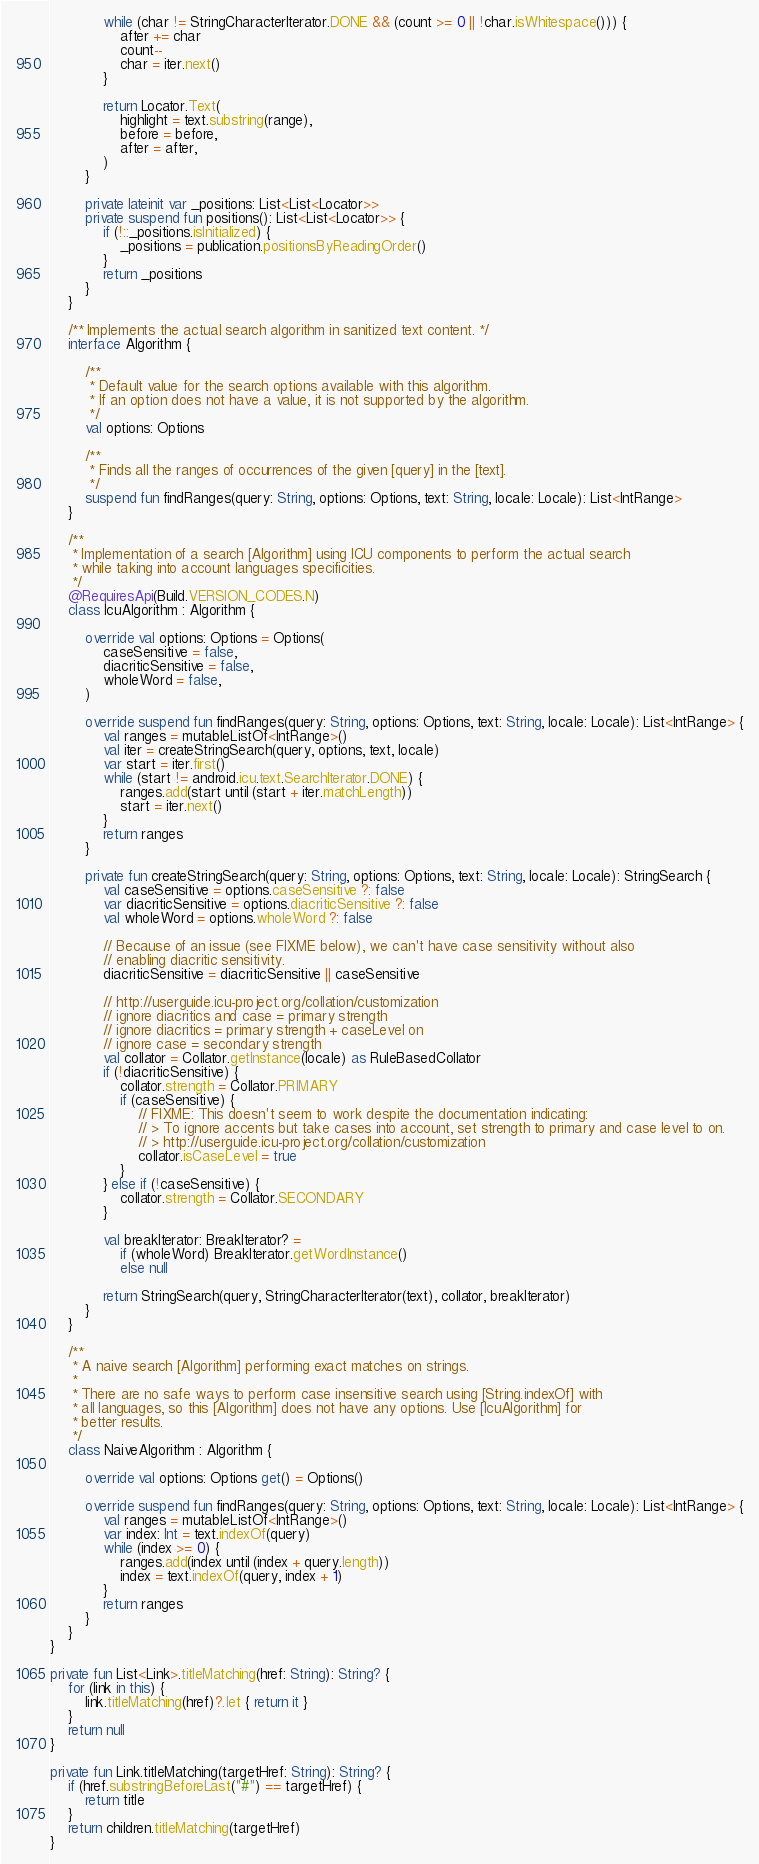Convert code to text. <code><loc_0><loc_0><loc_500><loc_500><_Kotlin_>            while (char != StringCharacterIterator.DONE && (count >= 0 || !char.isWhitespace())) {
                after += char
                count--
                char = iter.next()
            }

            return Locator.Text(
                highlight = text.substring(range),
                before = before,
                after = after,
            )
        }

        private lateinit var _positions: List<List<Locator>>
        private suspend fun positions(): List<List<Locator>> {
            if (!::_positions.isInitialized) {
                _positions = publication.positionsByReadingOrder()
            }
            return _positions
        }
    }

    /** Implements the actual search algorithm in sanitized text content. */
    interface Algorithm {

        /**
         * Default value for the search options available with this algorithm.
         * If an option does not have a value, it is not supported by the algorithm.
         */
        val options: Options

        /**
         * Finds all the ranges of occurrences of the given [query] in the [text].
         */
        suspend fun findRanges(query: String, options: Options, text: String, locale: Locale): List<IntRange>
    }

    /**
     * Implementation of a search [Algorithm] using ICU components to perform the actual search
     * while taking into account languages specificities.
     */
    @RequiresApi(Build.VERSION_CODES.N)
    class IcuAlgorithm : Algorithm {

        override val options: Options = Options(
            caseSensitive = false,
            diacriticSensitive = false,
            wholeWord = false,
        )

        override suspend fun findRanges(query: String, options: Options, text: String, locale: Locale): List<IntRange> {
            val ranges = mutableListOf<IntRange>()
            val iter = createStringSearch(query, options, text, locale)
            var start = iter.first()
            while (start != android.icu.text.SearchIterator.DONE) {
                ranges.add(start until (start + iter.matchLength))
                start = iter.next()
            }
            return ranges
        }

        private fun createStringSearch(query: String, options: Options, text: String, locale: Locale): StringSearch {
            val caseSensitive = options.caseSensitive ?: false
            var diacriticSensitive = options.diacriticSensitive ?: false
            val wholeWord = options.wholeWord ?: false

            // Because of an issue (see FIXME below), we can't have case sensitivity without also
            // enabling diacritic sensitivity.
            diacriticSensitive = diacriticSensitive || caseSensitive

            // http://userguide.icu-project.org/collation/customization
            // ignore diacritics and case = primary strength
            // ignore diacritics = primary strength + caseLevel on
            // ignore case = secondary strength
            val collator = Collator.getInstance(locale) as RuleBasedCollator
            if (!diacriticSensitive) {
                collator.strength = Collator.PRIMARY
                if (caseSensitive) {
                    // FIXME: This doesn't seem to work despite the documentation indicating:
                    // > To ignore accents but take cases into account, set strength to primary and case level to on.
                    // > http://userguide.icu-project.org/collation/customization
                    collator.isCaseLevel = true
                }
            } else if (!caseSensitive) {
                collator.strength = Collator.SECONDARY
            }

            val breakIterator: BreakIterator? =
                if (wholeWord) BreakIterator.getWordInstance()
                else null

            return StringSearch(query, StringCharacterIterator(text), collator, breakIterator)
        }
    }

    /**
     * A naive search [Algorithm] performing exact matches on strings.
     *
     * There are no safe ways to perform case insensitive search using [String.indexOf] with
     * all languages, so this [Algorithm] does not have any options. Use [IcuAlgorithm] for
     * better results.
     */
    class NaiveAlgorithm : Algorithm {

        override val options: Options get() = Options()

        override suspend fun findRanges(query: String, options: Options, text: String, locale: Locale): List<IntRange> {
            val ranges = mutableListOf<IntRange>()
            var index: Int = text.indexOf(query)
            while (index >= 0) {
                ranges.add(index until (index + query.length))
                index = text.indexOf(query, index + 1)
            }
            return ranges
        }
    }
}

private fun List<Link>.titleMatching(href: String): String? {
    for (link in this) {
        link.titleMatching(href)?.let { return it }
    }
    return null
}

private fun Link.titleMatching(targetHref: String): String? {
    if (href.substringBeforeLast("#") == targetHref) {
        return title
    }
    return children.titleMatching(targetHref)
}
</code> 